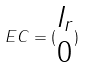<formula> <loc_0><loc_0><loc_500><loc_500>E C = ( \begin{matrix} I _ { r } \\ 0 \end{matrix} )</formula> 